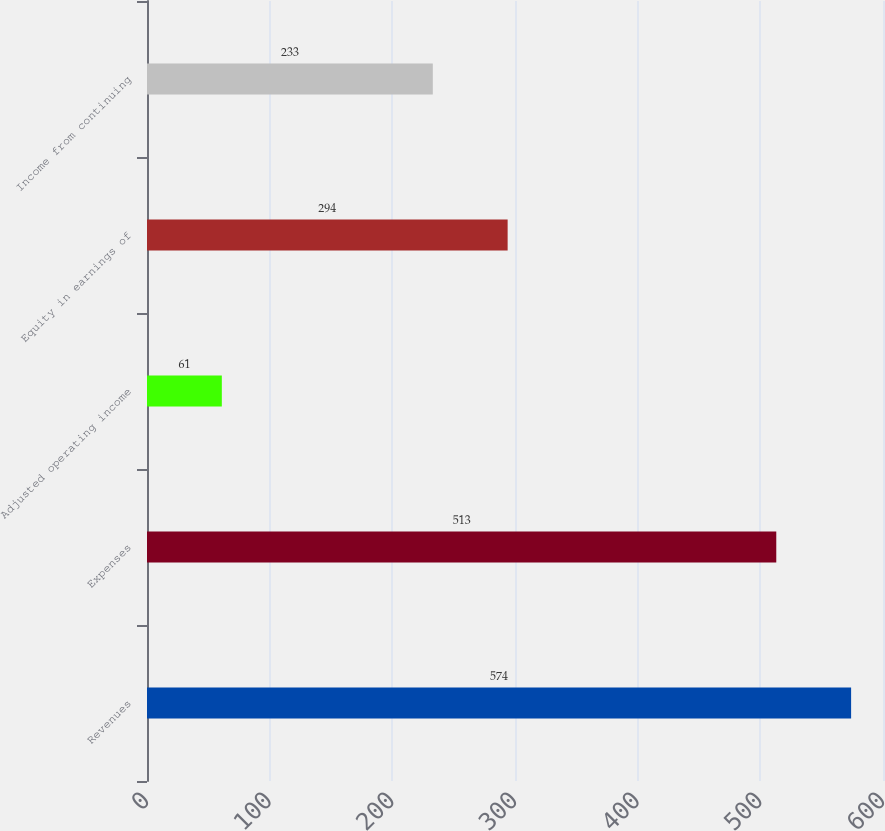<chart> <loc_0><loc_0><loc_500><loc_500><bar_chart><fcel>Revenues<fcel>Expenses<fcel>Adjusted operating income<fcel>Equity in earnings of<fcel>Income from continuing<nl><fcel>574<fcel>513<fcel>61<fcel>294<fcel>233<nl></chart> 